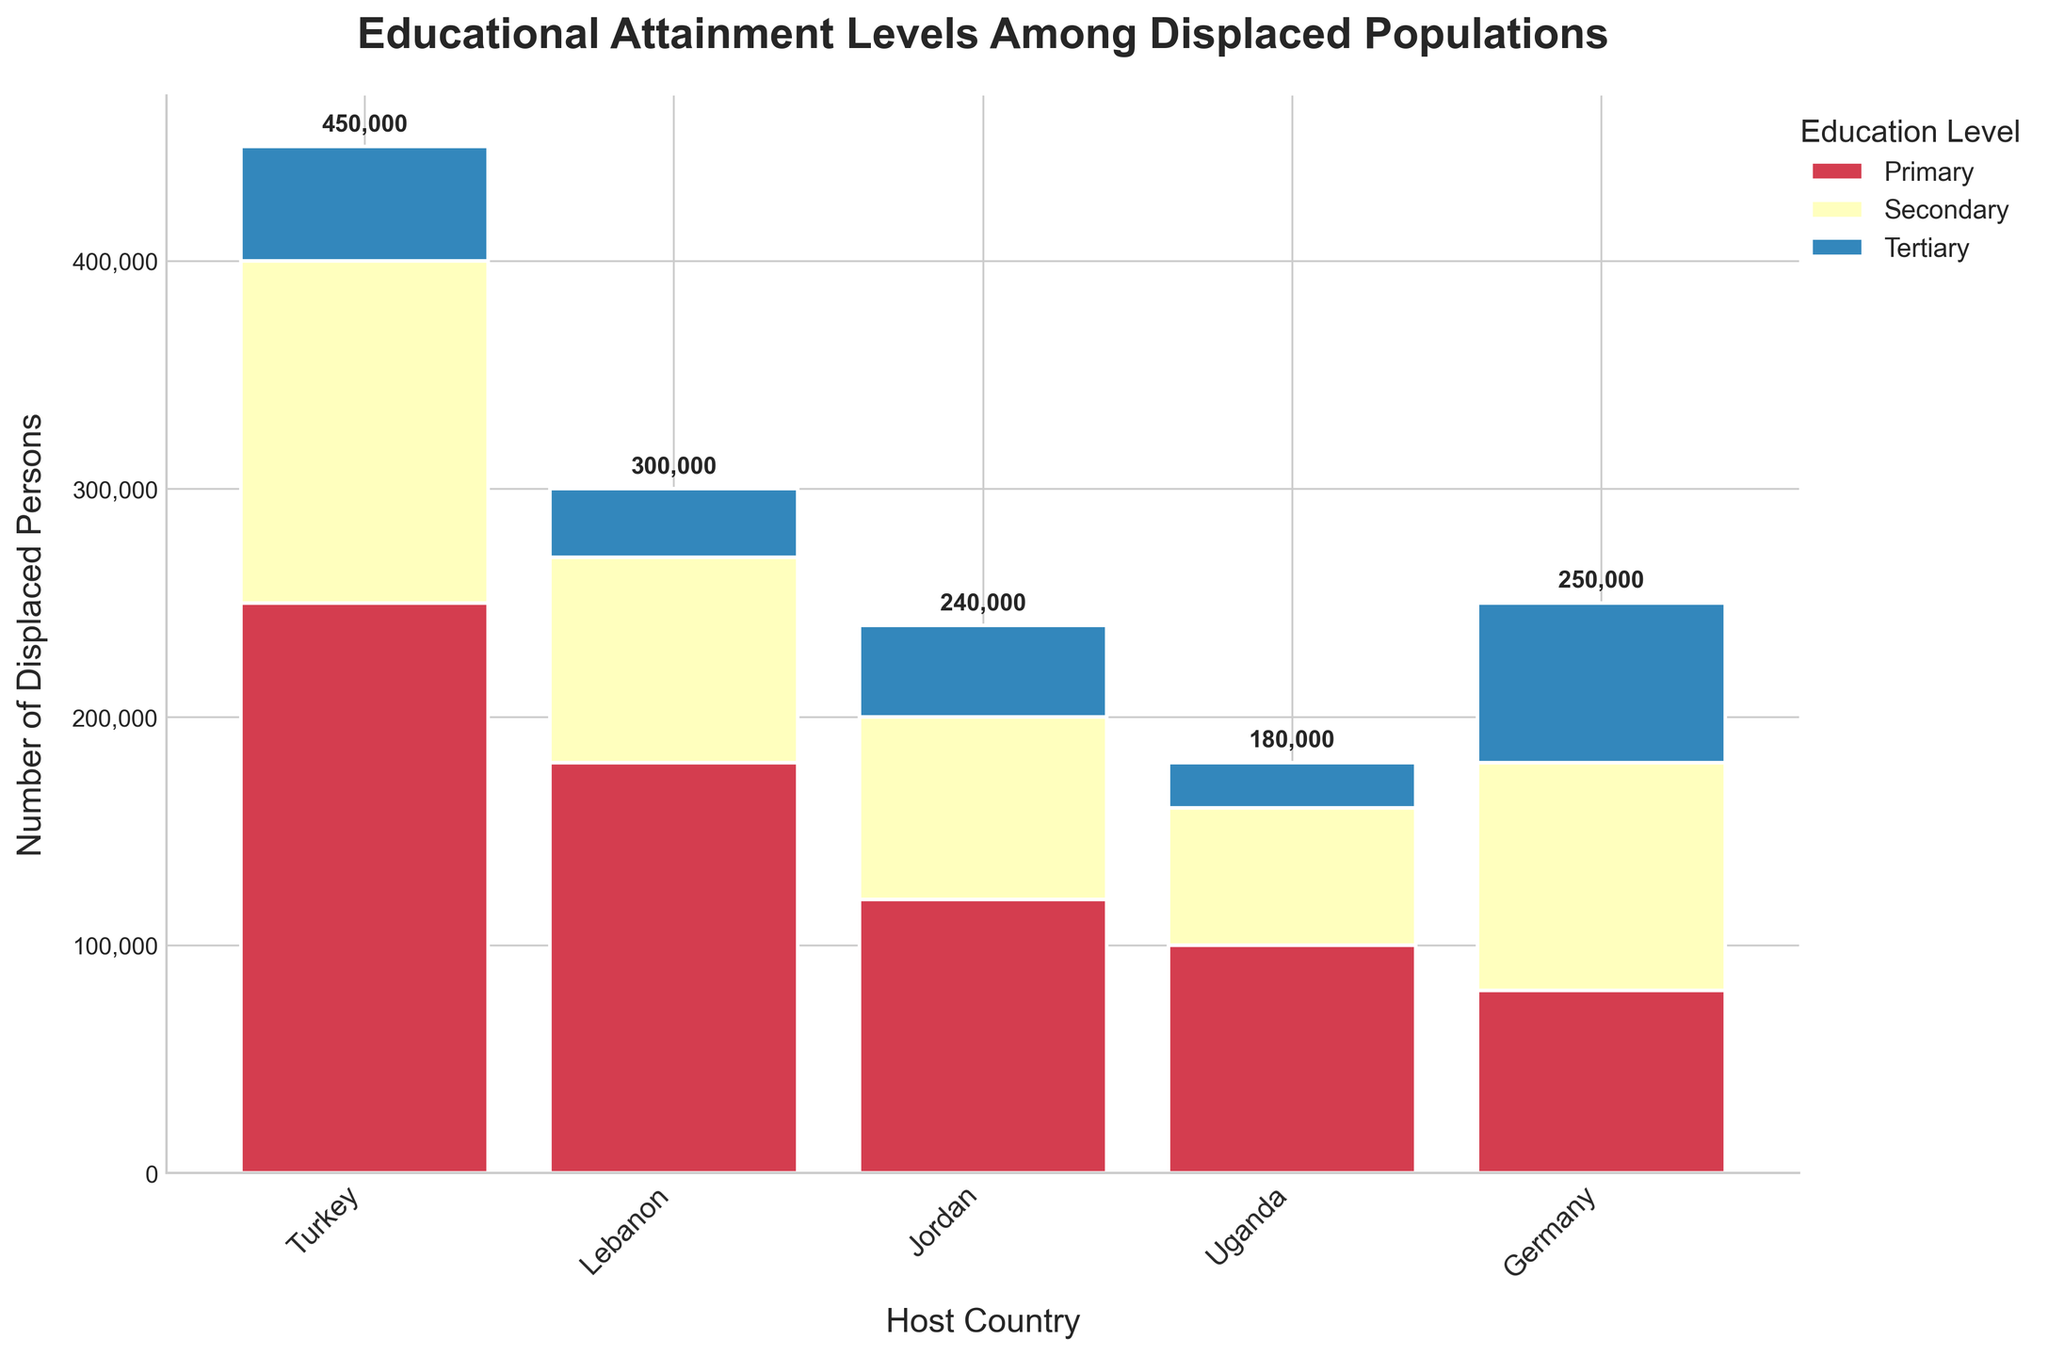What is the title of the figure? The figure has a clear title placed at the top, usually in a larger and bolder font compared to other texts on the graph. A glance at the top section will show the title.
Answer: Educational Attainment Levels Among Displaced Populations Which education level has the highest number of displaced persons in Turkey? To determine this, look at the bars corresponding to Turkey and compare the portion sizes for each education level. The tallest section indicates the highest number of displaced persons.
Answer: Primary How many displaced persons in Jordan have tertiary education? To find this, look at the bar section for Jordan and check the height of the part labeled as tertiary education. The number is indicated near the top of this section.
Answer: 40,000 What is the total number of displaced persons in Germany across all education levels? Sum up the heights of all sections of the bar corresponding to Germany. The number at the top of the bar also indicates the total.
Answer: 250,000 Which host country has the smallest number of displaced persons with primary education? Compare the heights of the primary education sections across all host countries. The smallest one corresponds to the country with the lowest number.
Answer: Germany How does the number of displaced persons with secondary education in Lebanon compare to those in Uganda? To answer this, compare the secondary education sections of the bars for Lebanon and Uganda. Check which one is higher to determine which country has more displaced persons.
Answer: Lebanon has more What is the difference in the number of displaced persons with tertiary education between Lebanon and Germany? Look at the bars for Lebanon and Germany, specifically at the tertiary education sections. Subtract the number for Lebanon from that of Germany to get the difference.
Answer: 40,000 Which country has the highest overall number of displaced persons? Examine the heights of the total bars for each country. The country with the tallest total bar has the highest overall number of displaced persons.
Answer: Turkey What's the total number of displaced persons located in Middle Eastern host countries combined? Identify the Middle Eastern countries (Turkey, Lebanon, Jordan), and sum their total number of displaced persons from their respective bars.
Answer: 890,000 